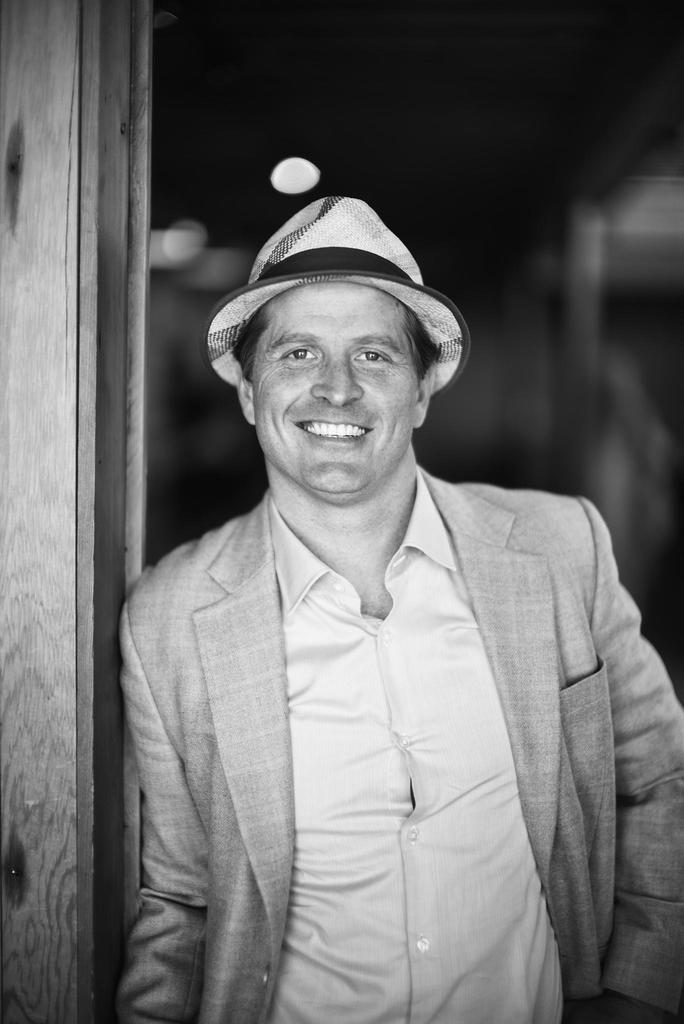What is the color scheme of the image? The image is black and white. Who is present in the image? There is a man in the image. What is the man wearing on his head? The man is wearing a hat. What is the man's facial expression in the image? The man is smiling. Where is the man standing in the image? The man is standing on a path. What can be observed about the background of the image? The background of the image is dark. What type of hook is the man using to play the game in the image? There is no hook or game present in the image; it features a man wearing a hat and smiling while standing on a path. What kind of cable is attached to the man's hat in the image? There is no cable attached to the man's hat in the image. 